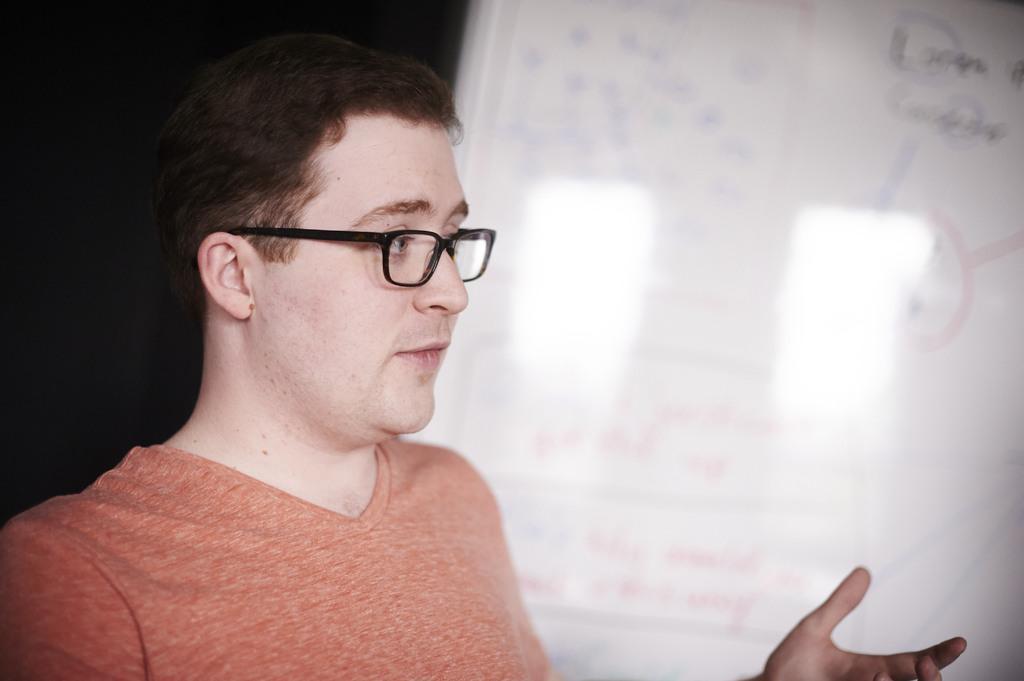Can you describe this image briefly? In this image we can see a person. There is a whiteboard at the right most of the image. 